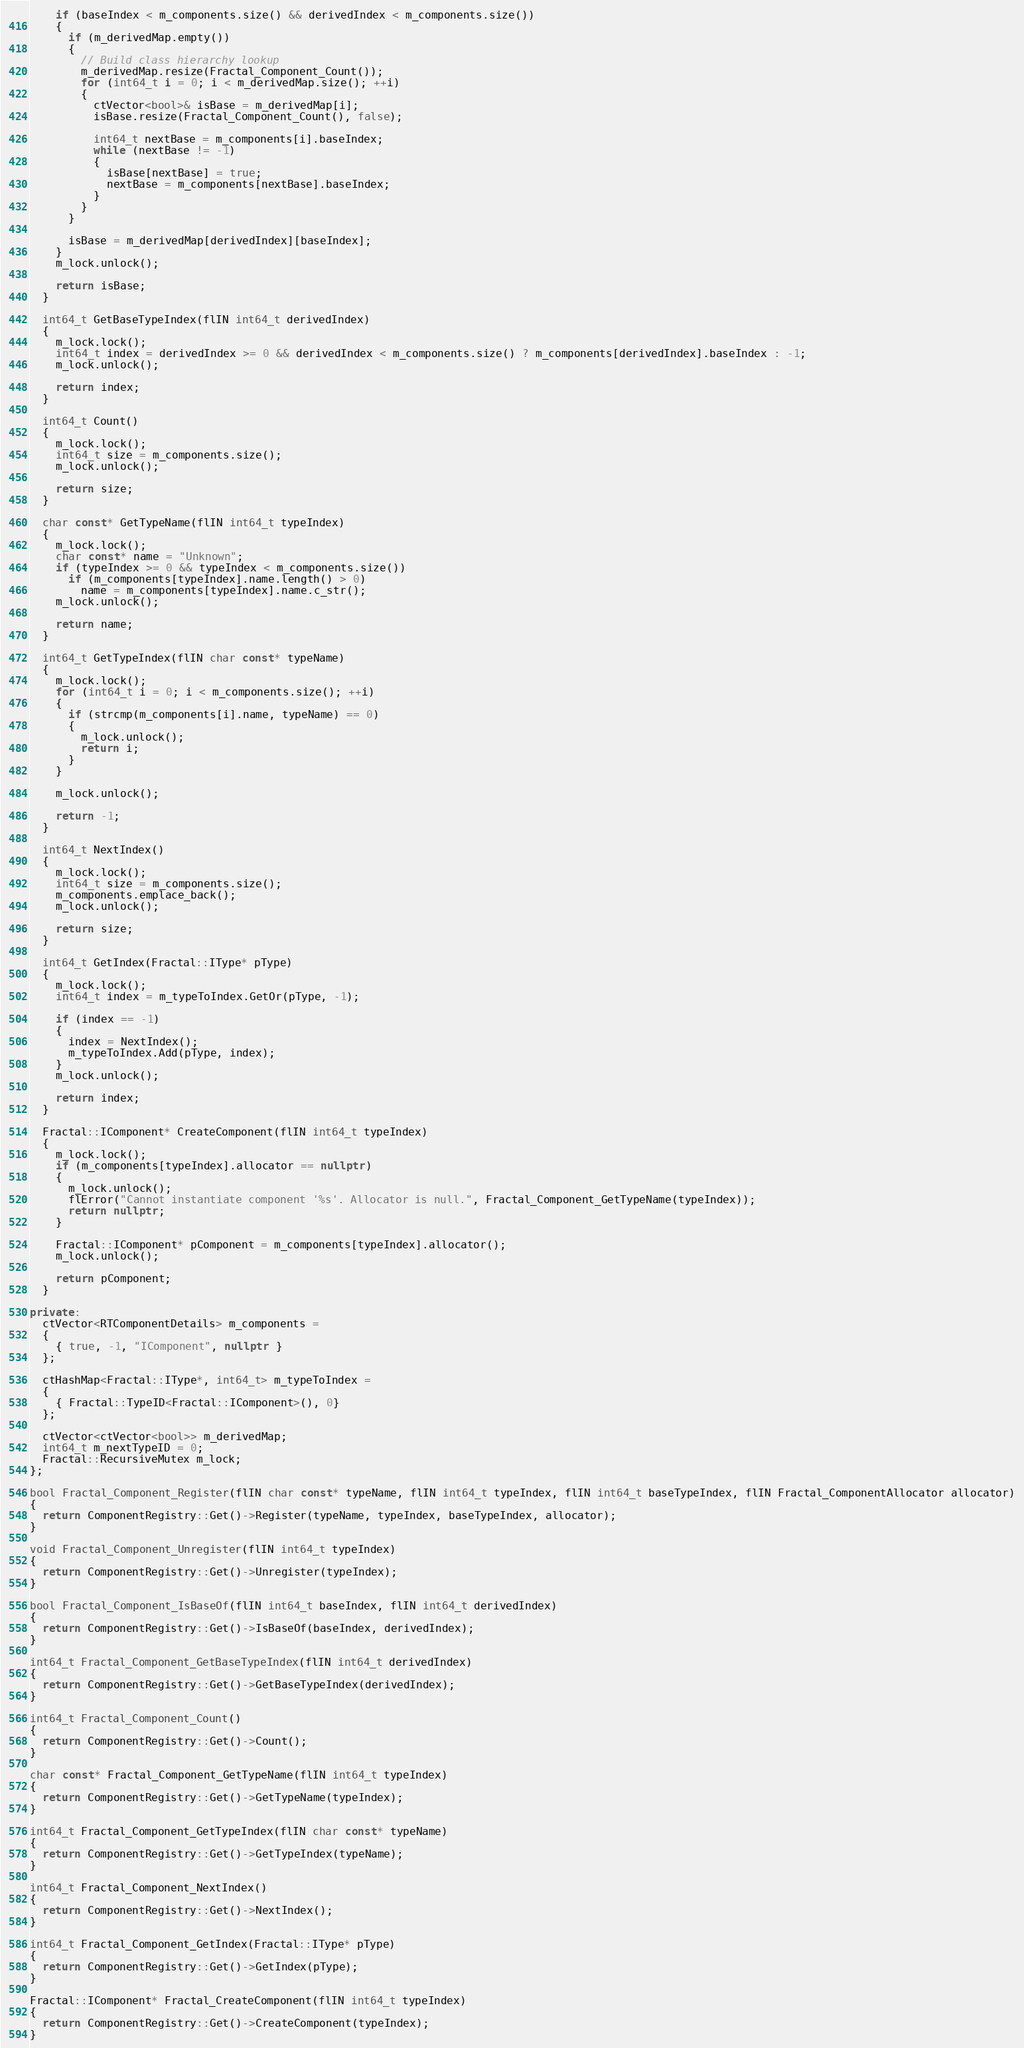Convert code to text. <code><loc_0><loc_0><loc_500><loc_500><_C++_>    if (baseIndex < m_components.size() && derivedIndex < m_components.size())
    {
      if (m_derivedMap.empty())
      {
        // Build class hierarchy lookup
        m_derivedMap.resize(Fractal_Component_Count());
        for (int64_t i = 0; i < m_derivedMap.size(); ++i)
        {
          ctVector<bool>& isBase = m_derivedMap[i];
          isBase.resize(Fractal_Component_Count(), false);

          int64_t nextBase = m_components[i].baseIndex;
          while (nextBase != -1)
          {
            isBase[nextBase] = true;
            nextBase = m_components[nextBase].baseIndex;
          }
        }
      }

      isBase = m_derivedMap[derivedIndex][baseIndex];
    }
    m_lock.unlock();

    return isBase;
  }

  int64_t GetBaseTypeIndex(flIN int64_t derivedIndex)
  {
    m_lock.lock();
    int64_t index = derivedIndex >= 0 && derivedIndex < m_components.size() ? m_components[derivedIndex].baseIndex : -1;
    m_lock.unlock();

    return index;
  }

  int64_t Count()
  {
    m_lock.lock();
    int64_t size = m_components.size();
    m_lock.unlock();

    return size;
  }

  char const* GetTypeName(flIN int64_t typeIndex)
  {
    m_lock.lock();
    char const* name = "Unknown";
    if (typeIndex >= 0 && typeIndex < m_components.size())
      if (m_components[typeIndex].name.length() > 0)
        name = m_components[typeIndex].name.c_str();
    m_lock.unlock();

    return name;
  }

  int64_t GetTypeIndex(flIN char const* typeName)
  {
    m_lock.lock();
    for (int64_t i = 0; i < m_components.size(); ++i)
    {
      if (strcmp(m_components[i].name, typeName) == 0)
      {
        m_lock.unlock();
        return i;
      }
    }

    m_lock.unlock();

    return -1;
  }

  int64_t NextIndex()
  {
    m_lock.lock();
    int64_t size = m_components.size();
    m_components.emplace_back();
    m_lock.unlock();

    return size;
  }

  int64_t GetIndex(Fractal::IType* pType)
  {
    m_lock.lock();
    int64_t index = m_typeToIndex.GetOr(pType, -1);

    if (index == -1)
    {
      index = NextIndex();
      m_typeToIndex.Add(pType, index);
    }
    m_lock.unlock();

    return index;
  }

  Fractal::IComponent* CreateComponent(flIN int64_t typeIndex)
  {
    m_lock.lock();
    if (m_components[typeIndex].allocator == nullptr)
    {
      m_lock.unlock();
      flError("Cannot instantiate component '%s'. Allocator is null.", Fractal_Component_GetTypeName(typeIndex));
      return nullptr;
    }

    Fractal::IComponent* pComponent = m_components[typeIndex].allocator();
    m_lock.unlock();

    return pComponent;
  }

private:
  ctVector<RTComponentDetails> m_components =
  {
    { true, -1, "IComponent", nullptr }
  };

  ctHashMap<Fractal::IType*, int64_t> m_typeToIndex =
  {
    { Fractal::TypeID<Fractal::IComponent>(), 0}
  };

  ctVector<ctVector<bool>> m_derivedMap;
  int64_t m_nextTypeID = 0;
  Fractal::RecursiveMutex m_lock;
};

bool Fractal_Component_Register(flIN char const* typeName, flIN int64_t typeIndex, flIN int64_t baseTypeIndex, flIN Fractal_ComponentAllocator allocator)
{
  return ComponentRegistry::Get()->Register(typeName, typeIndex, baseTypeIndex, allocator);
}

void Fractal_Component_Unregister(flIN int64_t typeIndex)
{
  return ComponentRegistry::Get()->Unregister(typeIndex);
}

bool Fractal_Component_IsBaseOf(flIN int64_t baseIndex, flIN int64_t derivedIndex)
{
  return ComponentRegistry::Get()->IsBaseOf(baseIndex, derivedIndex);
}

int64_t Fractal_Component_GetBaseTypeIndex(flIN int64_t derivedIndex)
{
  return ComponentRegistry::Get()->GetBaseTypeIndex(derivedIndex);
}

int64_t Fractal_Component_Count()
{
  return ComponentRegistry::Get()->Count();
}

char const* Fractal_Component_GetTypeName(flIN int64_t typeIndex)
{
  return ComponentRegistry::Get()->GetTypeName(typeIndex);
}

int64_t Fractal_Component_GetTypeIndex(flIN char const* typeName)
{
  return ComponentRegistry::Get()->GetTypeIndex(typeName);
}

int64_t Fractal_Component_NextIndex()
{
  return ComponentRegistry::Get()->NextIndex();
}

int64_t Fractal_Component_GetIndex(Fractal::IType* pType)
{
  return ComponentRegistry::Get()->GetIndex(pType);
}

Fractal::IComponent* Fractal_CreateComponent(flIN int64_t typeIndex)
{
  return ComponentRegistry::Get()->CreateComponent(typeIndex);
}
</code> 